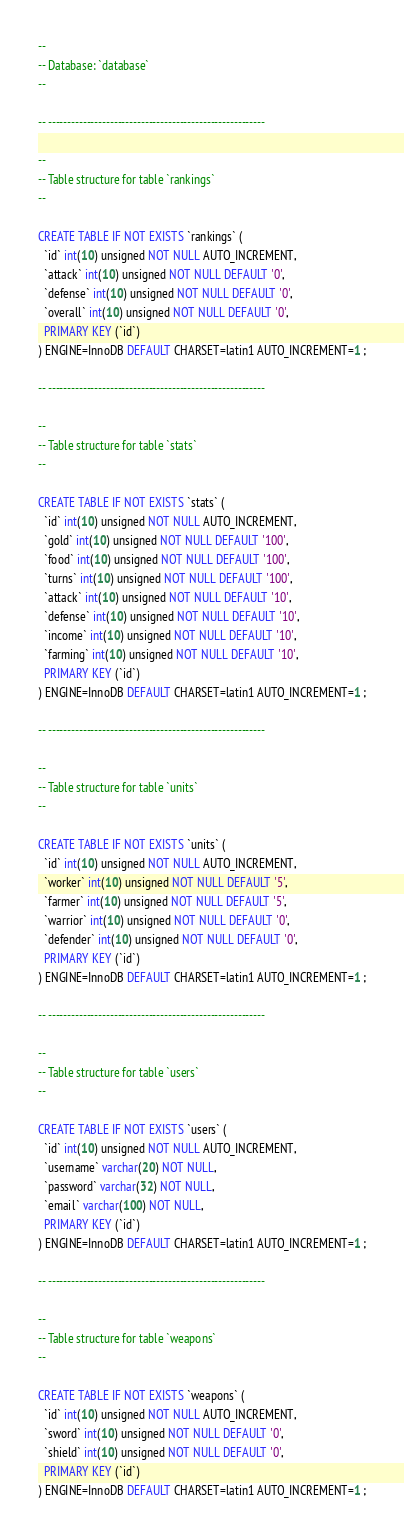<code> <loc_0><loc_0><loc_500><loc_500><_SQL_>--
-- Database: `database`
--

-- --------------------------------------------------------

--
-- Table structure for table `rankings`
--

CREATE TABLE IF NOT EXISTS `rankings` (
  `id` int(10) unsigned NOT NULL AUTO_INCREMENT,
  `attack` int(10) unsigned NOT NULL DEFAULT '0',
  `defense` int(10) unsigned NOT NULL DEFAULT '0',
  `overall` int(10) unsigned NOT NULL DEFAULT '0',
  PRIMARY KEY (`id`)
) ENGINE=InnoDB DEFAULT CHARSET=latin1 AUTO_INCREMENT=1 ;

-- --------------------------------------------------------

--
-- Table structure for table `stats`
--

CREATE TABLE IF NOT EXISTS `stats` (
  `id` int(10) unsigned NOT NULL AUTO_INCREMENT,
  `gold` int(10) unsigned NOT NULL DEFAULT '100',
  `food` int(10) unsigned NOT NULL DEFAULT '100',
  `turns` int(10) unsigned NOT NULL DEFAULT '100',
  `attack` int(10) unsigned NOT NULL DEFAULT '10',
  `defense` int(10) unsigned NOT NULL DEFAULT '10',
  `income` int(10) unsigned NOT NULL DEFAULT '10',
  `farming` int(10) unsigned NOT NULL DEFAULT '10',
  PRIMARY KEY (`id`)
) ENGINE=InnoDB DEFAULT CHARSET=latin1 AUTO_INCREMENT=1 ;

-- --------------------------------------------------------

--
-- Table structure for table `units`
--

CREATE TABLE IF NOT EXISTS `units` (
  `id` int(10) unsigned NOT NULL AUTO_INCREMENT,
  `worker` int(10) unsigned NOT NULL DEFAULT '5',
  `farmer` int(10) unsigned NOT NULL DEFAULT '5',
  `warrior` int(10) unsigned NOT NULL DEFAULT '0',
  `defender` int(10) unsigned NOT NULL DEFAULT '0',
  PRIMARY KEY (`id`)
) ENGINE=InnoDB DEFAULT CHARSET=latin1 AUTO_INCREMENT=1 ;

-- --------------------------------------------------------

--
-- Table structure for table `users`
--

CREATE TABLE IF NOT EXISTS `users` (
  `id` int(10) unsigned NOT NULL AUTO_INCREMENT,
  `username` varchar(20) NOT NULL,
  `password` varchar(32) NOT NULL,
  `email` varchar(100) NOT NULL,
  PRIMARY KEY (`id`)
) ENGINE=InnoDB DEFAULT CHARSET=latin1 AUTO_INCREMENT=1 ;

-- --------------------------------------------------------

--
-- Table structure for table `weapons`
--

CREATE TABLE IF NOT EXISTS `weapons` (
  `id` int(10) unsigned NOT NULL AUTO_INCREMENT,
  `sword` int(10) unsigned NOT NULL DEFAULT '0',
  `shield` int(10) unsigned NOT NULL DEFAULT '0',
  PRIMARY KEY (`id`)
) ENGINE=InnoDB DEFAULT CHARSET=latin1 AUTO_INCREMENT=1 ;</code> 